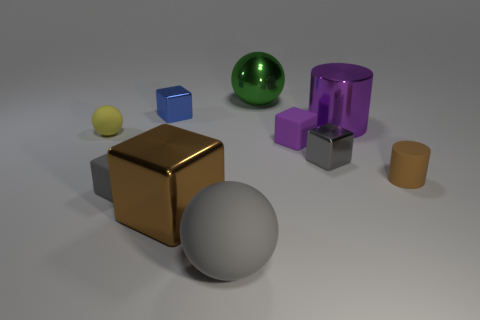Do the yellow object and the big green metallic thing have the same shape?
Offer a very short reply. Yes. Do the green metallic ball and the gray sphere have the same size?
Your answer should be very brief. Yes. Does the big object right of the metallic sphere have the same material as the small cylinder?
Provide a succinct answer. No. What number of purple cylinders are on the right side of the small gray object that is in front of the object on the right side of the big cylinder?
Offer a terse response. 1. There is a tiny metal thing to the right of the large matte ball; does it have the same shape as the blue thing?
Offer a terse response. Yes. What number of things are big yellow metal blocks or tiny rubber things that are on the left side of the big purple object?
Your response must be concise. 3. Is the number of matte things that are in front of the tiny rubber sphere greater than the number of rubber blocks?
Ensure brevity in your answer.  Yes. Are there the same number of large balls that are right of the purple block and shiny things in front of the shiny ball?
Offer a very short reply. No. There is a tiny metallic block that is on the right side of the big gray thing; are there any balls that are behind it?
Make the answer very short. Yes. What shape is the tiny yellow matte thing?
Your response must be concise. Sphere. 